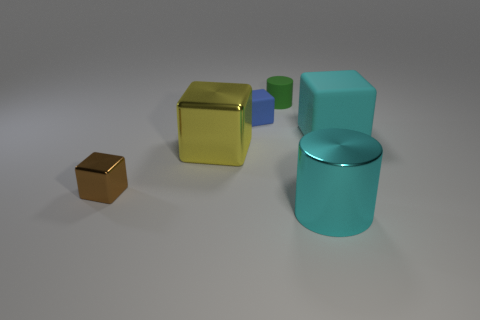Is the number of metallic objects behind the tiny metallic thing less than the number of matte cylinders in front of the blue rubber thing?
Your answer should be very brief. No. What material is the tiny cube that is in front of the large cube left of the small matte thing in front of the tiny green thing made of?
Your response must be concise. Metal. There is a object that is both in front of the big yellow metal thing and right of the big yellow object; how big is it?
Give a very brief answer. Large. What number of cylinders are either small red rubber things or matte things?
Ensure brevity in your answer.  1. What color is the matte object that is the same size as the yellow block?
Provide a succinct answer. Cyan. Is there anything else that is the same shape as the tiny brown metal object?
Offer a very short reply. Yes. There is another large shiny object that is the same shape as the brown object; what color is it?
Provide a short and direct response. Yellow. How many things are either matte objects or rubber cubes on the left side of the tiny cylinder?
Offer a very short reply. 3. Are there fewer small cylinders in front of the green rubber cylinder than cylinders?
Ensure brevity in your answer.  Yes. There is a rubber thing that is on the right side of the big cylinder in front of the tiny rubber cylinder that is behind the large metallic cylinder; what is its size?
Provide a succinct answer. Large. 